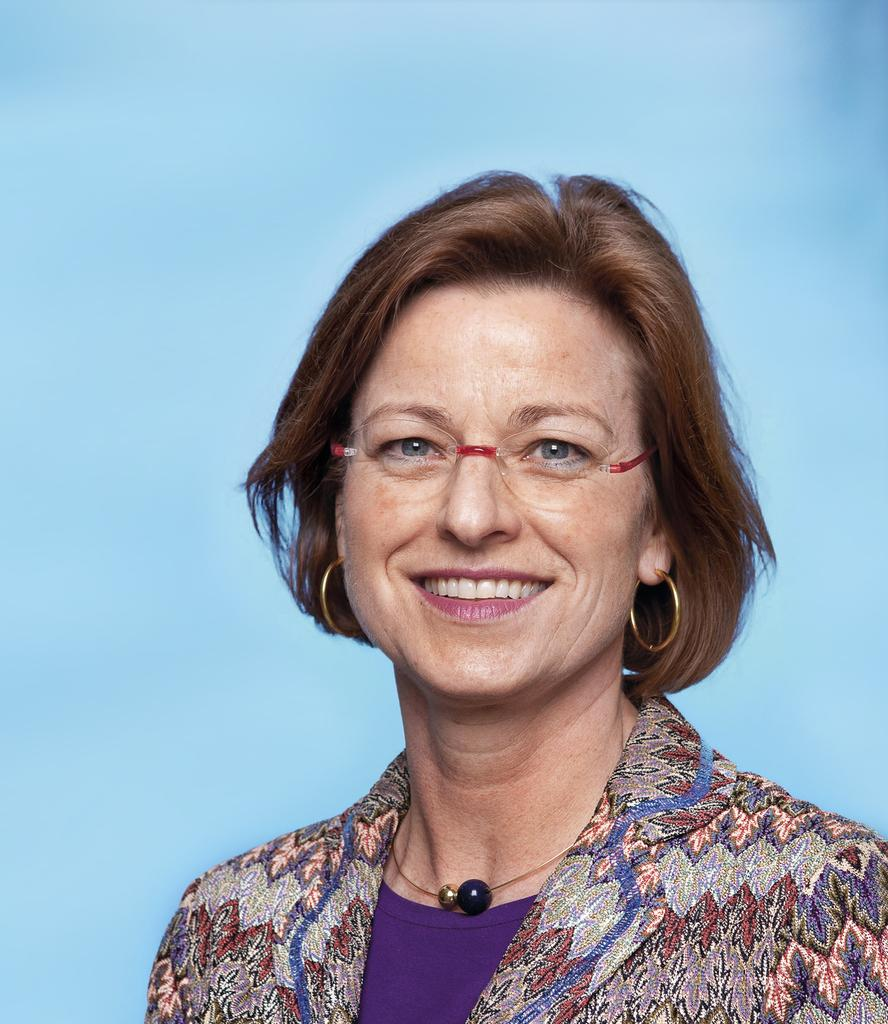Who is the main subject in the foreground of the image? There is a woman in the foreground of the image. What is the woman's expression in the image? The woman is smiling in the image. What color is the background of the image? The background of the image is sky blue. How many daughters can be seen running through the leaves in the image? There are no daughters or leaves present in the image. 